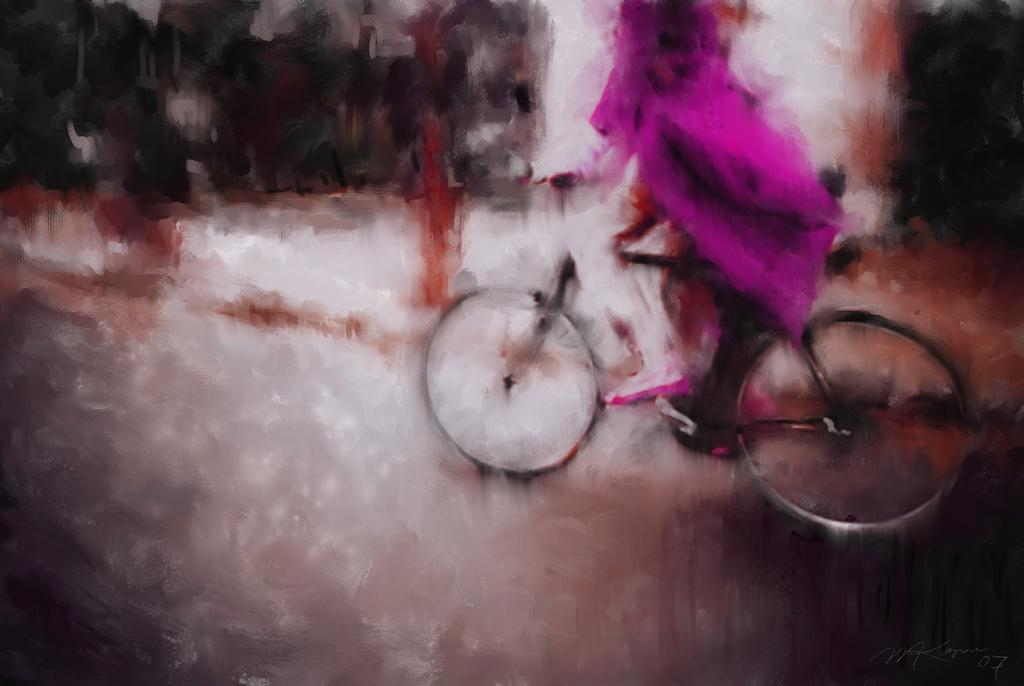What is the main subject of the image? There is a painting in the image. What is the painting depicting? The painting depicts a person riding a bicycle. What type of impulse can be seen affecting the person riding the bicycle in the image? There is no impulse affecting the person riding the bicycle in the image; it is a static painting. What is the thumb doing in the image? There is no thumb present in the image; it is a painting of a person riding a bicycle. 